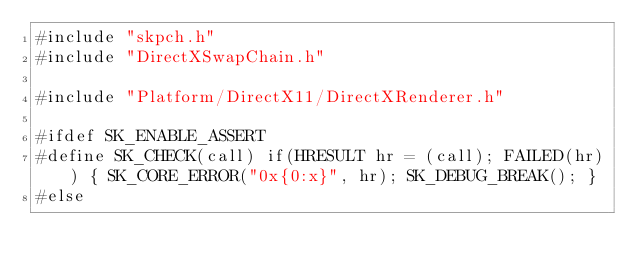<code> <loc_0><loc_0><loc_500><loc_500><_C++_>#include "skpch.h"
#include "DirectXSwapChain.h"

#include "Platform/DirectX11/DirectXRenderer.h"

#ifdef SK_ENABLE_ASSERT
#define SK_CHECK(call) if(HRESULT hr = (call); FAILED(hr)) { SK_CORE_ERROR("0x{0:x}", hr); SK_DEBUG_BREAK(); }
#else</code> 